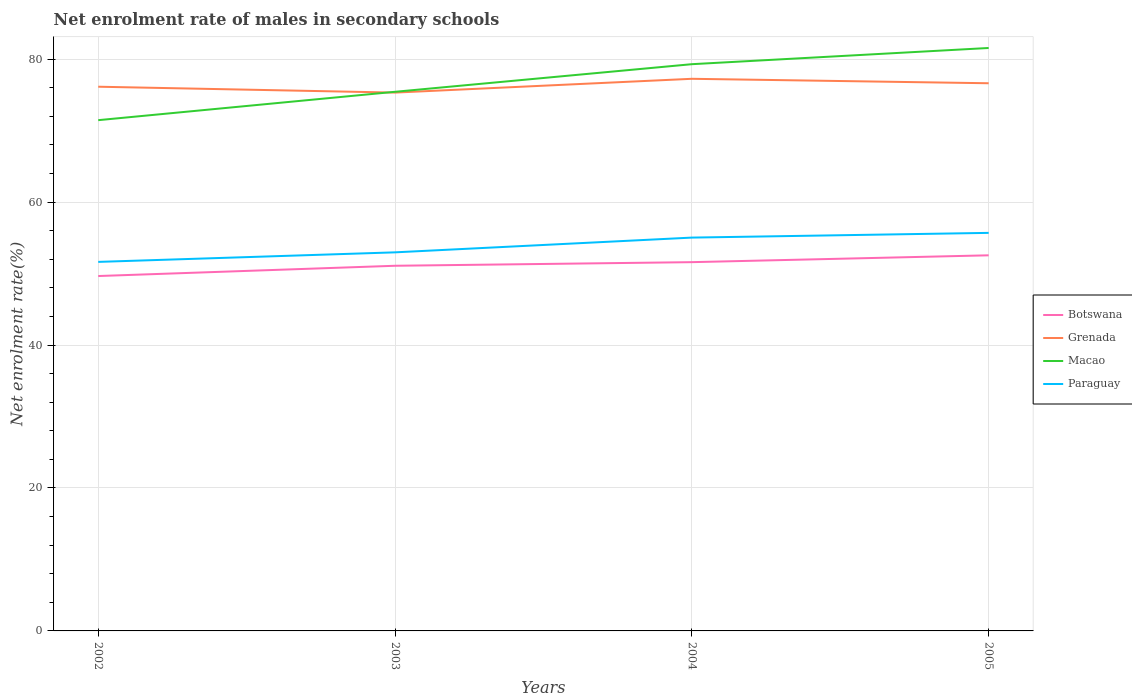How many different coloured lines are there?
Offer a very short reply. 4. Is the number of lines equal to the number of legend labels?
Offer a terse response. Yes. Across all years, what is the maximum net enrolment rate of males in secondary schools in Botswana?
Your answer should be very brief. 49.65. In which year was the net enrolment rate of males in secondary schools in Paraguay maximum?
Provide a succinct answer. 2002. What is the total net enrolment rate of males in secondary schools in Paraguay in the graph?
Provide a short and direct response. -0.66. What is the difference between the highest and the second highest net enrolment rate of males in secondary schools in Grenada?
Provide a short and direct response. 1.93. How many years are there in the graph?
Ensure brevity in your answer.  4. Are the values on the major ticks of Y-axis written in scientific E-notation?
Make the answer very short. No. Does the graph contain any zero values?
Make the answer very short. No. Does the graph contain grids?
Give a very brief answer. Yes. How many legend labels are there?
Ensure brevity in your answer.  4. What is the title of the graph?
Provide a succinct answer. Net enrolment rate of males in secondary schools. Does "Chile" appear as one of the legend labels in the graph?
Give a very brief answer. No. What is the label or title of the X-axis?
Ensure brevity in your answer.  Years. What is the label or title of the Y-axis?
Your answer should be very brief. Net enrolment rate(%). What is the Net enrolment rate(%) in Botswana in 2002?
Provide a succinct answer. 49.65. What is the Net enrolment rate(%) of Grenada in 2002?
Provide a succinct answer. 76.14. What is the Net enrolment rate(%) in Macao in 2002?
Keep it short and to the point. 71.46. What is the Net enrolment rate(%) in Paraguay in 2002?
Your response must be concise. 51.63. What is the Net enrolment rate(%) of Botswana in 2003?
Offer a terse response. 51.09. What is the Net enrolment rate(%) in Grenada in 2003?
Your response must be concise. 75.32. What is the Net enrolment rate(%) in Macao in 2003?
Your response must be concise. 75.43. What is the Net enrolment rate(%) of Paraguay in 2003?
Your answer should be compact. 52.96. What is the Net enrolment rate(%) in Botswana in 2004?
Provide a succinct answer. 51.59. What is the Net enrolment rate(%) of Grenada in 2004?
Your answer should be compact. 77.24. What is the Net enrolment rate(%) of Macao in 2004?
Keep it short and to the point. 79.29. What is the Net enrolment rate(%) in Paraguay in 2004?
Offer a terse response. 55.03. What is the Net enrolment rate(%) in Botswana in 2005?
Keep it short and to the point. 52.55. What is the Net enrolment rate(%) in Grenada in 2005?
Your response must be concise. 76.62. What is the Net enrolment rate(%) of Macao in 2005?
Keep it short and to the point. 81.56. What is the Net enrolment rate(%) in Paraguay in 2005?
Offer a terse response. 55.69. Across all years, what is the maximum Net enrolment rate(%) of Botswana?
Keep it short and to the point. 52.55. Across all years, what is the maximum Net enrolment rate(%) in Grenada?
Offer a very short reply. 77.24. Across all years, what is the maximum Net enrolment rate(%) of Macao?
Make the answer very short. 81.56. Across all years, what is the maximum Net enrolment rate(%) in Paraguay?
Provide a short and direct response. 55.69. Across all years, what is the minimum Net enrolment rate(%) in Botswana?
Offer a terse response. 49.65. Across all years, what is the minimum Net enrolment rate(%) in Grenada?
Offer a terse response. 75.32. Across all years, what is the minimum Net enrolment rate(%) in Macao?
Your answer should be very brief. 71.46. Across all years, what is the minimum Net enrolment rate(%) in Paraguay?
Provide a short and direct response. 51.63. What is the total Net enrolment rate(%) of Botswana in the graph?
Ensure brevity in your answer.  204.88. What is the total Net enrolment rate(%) in Grenada in the graph?
Ensure brevity in your answer.  305.32. What is the total Net enrolment rate(%) in Macao in the graph?
Make the answer very short. 307.73. What is the total Net enrolment rate(%) in Paraguay in the graph?
Offer a terse response. 215.31. What is the difference between the Net enrolment rate(%) of Botswana in 2002 and that in 2003?
Provide a short and direct response. -1.44. What is the difference between the Net enrolment rate(%) of Grenada in 2002 and that in 2003?
Make the answer very short. 0.82. What is the difference between the Net enrolment rate(%) of Macao in 2002 and that in 2003?
Offer a very short reply. -3.97. What is the difference between the Net enrolment rate(%) of Paraguay in 2002 and that in 2003?
Keep it short and to the point. -1.34. What is the difference between the Net enrolment rate(%) in Botswana in 2002 and that in 2004?
Offer a very short reply. -1.94. What is the difference between the Net enrolment rate(%) of Grenada in 2002 and that in 2004?
Offer a terse response. -1.11. What is the difference between the Net enrolment rate(%) in Macao in 2002 and that in 2004?
Provide a succinct answer. -7.83. What is the difference between the Net enrolment rate(%) in Paraguay in 2002 and that in 2004?
Ensure brevity in your answer.  -3.4. What is the difference between the Net enrolment rate(%) in Botswana in 2002 and that in 2005?
Provide a succinct answer. -2.9. What is the difference between the Net enrolment rate(%) in Grenada in 2002 and that in 2005?
Your answer should be compact. -0.48. What is the difference between the Net enrolment rate(%) in Macao in 2002 and that in 2005?
Provide a short and direct response. -10.1. What is the difference between the Net enrolment rate(%) in Paraguay in 2002 and that in 2005?
Your answer should be compact. -4.06. What is the difference between the Net enrolment rate(%) of Botswana in 2003 and that in 2004?
Keep it short and to the point. -0.51. What is the difference between the Net enrolment rate(%) in Grenada in 2003 and that in 2004?
Your response must be concise. -1.93. What is the difference between the Net enrolment rate(%) of Macao in 2003 and that in 2004?
Keep it short and to the point. -3.86. What is the difference between the Net enrolment rate(%) in Paraguay in 2003 and that in 2004?
Offer a very short reply. -2.06. What is the difference between the Net enrolment rate(%) of Botswana in 2003 and that in 2005?
Your answer should be compact. -1.46. What is the difference between the Net enrolment rate(%) of Grenada in 2003 and that in 2005?
Keep it short and to the point. -1.31. What is the difference between the Net enrolment rate(%) in Macao in 2003 and that in 2005?
Make the answer very short. -6.13. What is the difference between the Net enrolment rate(%) in Paraguay in 2003 and that in 2005?
Provide a succinct answer. -2.72. What is the difference between the Net enrolment rate(%) in Botswana in 2004 and that in 2005?
Provide a short and direct response. -0.96. What is the difference between the Net enrolment rate(%) of Grenada in 2004 and that in 2005?
Ensure brevity in your answer.  0.62. What is the difference between the Net enrolment rate(%) in Macao in 2004 and that in 2005?
Offer a very short reply. -2.27. What is the difference between the Net enrolment rate(%) of Paraguay in 2004 and that in 2005?
Keep it short and to the point. -0.66. What is the difference between the Net enrolment rate(%) in Botswana in 2002 and the Net enrolment rate(%) in Grenada in 2003?
Offer a terse response. -25.66. What is the difference between the Net enrolment rate(%) in Botswana in 2002 and the Net enrolment rate(%) in Macao in 2003?
Provide a short and direct response. -25.78. What is the difference between the Net enrolment rate(%) of Botswana in 2002 and the Net enrolment rate(%) of Paraguay in 2003?
Your answer should be very brief. -3.31. What is the difference between the Net enrolment rate(%) in Grenada in 2002 and the Net enrolment rate(%) in Macao in 2003?
Provide a short and direct response. 0.71. What is the difference between the Net enrolment rate(%) of Grenada in 2002 and the Net enrolment rate(%) of Paraguay in 2003?
Make the answer very short. 23.17. What is the difference between the Net enrolment rate(%) of Macao in 2002 and the Net enrolment rate(%) of Paraguay in 2003?
Offer a terse response. 18.49. What is the difference between the Net enrolment rate(%) of Botswana in 2002 and the Net enrolment rate(%) of Grenada in 2004?
Keep it short and to the point. -27.59. What is the difference between the Net enrolment rate(%) of Botswana in 2002 and the Net enrolment rate(%) of Macao in 2004?
Make the answer very short. -29.64. What is the difference between the Net enrolment rate(%) in Botswana in 2002 and the Net enrolment rate(%) in Paraguay in 2004?
Keep it short and to the point. -5.38. What is the difference between the Net enrolment rate(%) of Grenada in 2002 and the Net enrolment rate(%) of Macao in 2004?
Your answer should be compact. -3.15. What is the difference between the Net enrolment rate(%) of Grenada in 2002 and the Net enrolment rate(%) of Paraguay in 2004?
Offer a very short reply. 21.11. What is the difference between the Net enrolment rate(%) of Macao in 2002 and the Net enrolment rate(%) of Paraguay in 2004?
Your response must be concise. 16.43. What is the difference between the Net enrolment rate(%) in Botswana in 2002 and the Net enrolment rate(%) in Grenada in 2005?
Provide a succinct answer. -26.97. What is the difference between the Net enrolment rate(%) of Botswana in 2002 and the Net enrolment rate(%) of Macao in 2005?
Ensure brevity in your answer.  -31.91. What is the difference between the Net enrolment rate(%) of Botswana in 2002 and the Net enrolment rate(%) of Paraguay in 2005?
Your response must be concise. -6.04. What is the difference between the Net enrolment rate(%) of Grenada in 2002 and the Net enrolment rate(%) of Macao in 2005?
Your answer should be compact. -5.42. What is the difference between the Net enrolment rate(%) in Grenada in 2002 and the Net enrolment rate(%) in Paraguay in 2005?
Keep it short and to the point. 20.45. What is the difference between the Net enrolment rate(%) in Macao in 2002 and the Net enrolment rate(%) in Paraguay in 2005?
Your response must be concise. 15.77. What is the difference between the Net enrolment rate(%) in Botswana in 2003 and the Net enrolment rate(%) in Grenada in 2004?
Make the answer very short. -26.16. What is the difference between the Net enrolment rate(%) in Botswana in 2003 and the Net enrolment rate(%) in Macao in 2004?
Ensure brevity in your answer.  -28.2. What is the difference between the Net enrolment rate(%) in Botswana in 2003 and the Net enrolment rate(%) in Paraguay in 2004?
Your answer should be compact. -3.94. What is the difference between the Net enrolment rate(%) of Grenada in 2003 and the Net enrolment rate(%) of Macao in 2004?
Provide a short and direct response. -3.97. What is the difference between the Net enrolment rate(%) in Grenada in 2003 and the Net enrolment rate(%) in Paraguay in 2004?
Give a very brief answer. 20.29. What is the difference between the Net enrolment rate(%) in Macao in 2003 and the Net enrolment rate(%) in Paraguay in 2004?
Offer a very short reply. 20.4. What is the difference between the Net enrolment rate(%) in Botswana in 2003 and the Net enrolment rate(%) in Grenada in 2005?
Make the answer very short. -25.53. What is the difference between the Net enrolment rate(%) of Botswana in 2003 and the Net enrolment rate(%) of Macao in 2005?
Offer a terse response. -30.47. What is the difference between the Net enrolment rate(%) in Botswana in 2003 and the Net enrolment rate(%) in Paraguay in 2005?
Your answer should be very brief. -4.6. What is the difference between the Net enrolment rate(%) of Grenada in 2003 and the Net enrolment rate(%) of Macao in 2005?
Make the answer very short. -6.24. What is the difference between the Net enrolment rate(%) in Grenada in 2003 and the Net enrolment rate(%) in Paraguay in 2005?
Your answer should be very brief. 19.63. What is the difference between the Net enrolment rate(%) of Macao in 2003 and the Net enrolment rate(%) of Paraguay in 2005?
Offer a terse response. 19.74. What is the difference between the Net enrolment rate(%) in Botswana in 2004 and the Net enrolment rate(%) in Grenada in 2005?
Offer a very short reply. -25.03. What is the difference between the Net enrolment rate(%) of Botswana in 2004 and the Net enrolment rate(%) of Macao in 2005?
Offer a terse response. -29.96. What is the difference between the Net enrolment rate(%) in Botswana in 2004 and the Net enrolment rate(%) in Paraguay in 2005?
Offer a very short reply. -4.1. What is the difference between the Net enrolment rate(%) of Grenada in 2004 and the Net enrolment rate(%) of Macao in 2005?
Offer a very short reply. -4.31. What is the difference between the Net enrolment rate(%) of Grenada in 2004 and the Net enrolment rate(%) of Paraguay in 2005?
Your response must be concise. 21.56. What is the difference between the Net enrolment rate(%) in Macao in 2004 and the Net enrolment rate(%) in Paraguay in 2005?
Your answer should be very brief. 23.6. What is the average Net enrolment rate(%) in Botswana per year?
Offer a terse response. 51.22. What is the average Net enrolment rate(%) of Grenada per year?
Offer a terse response. 76.33. What is the average Net enrolment rate(%) of Macao per year?
Your response must be concise. 76.93. What is the average Net enrolment rate(%) of Paraguay per year?
Offer a very short reply. 53.83. In the year 2002, what is the difference between the Net enrolment rate(%) in Botswana and Net enrolment rate(%) in Grenada?
Offer a terse response. -26.49. In the year 2002, what is the difference between the Net enrolment rate(%) of Botswana and Net enrolment rate(%) of Macao?
Keep it short and to the point. -21.81. In the year 2002, what is the difference between the Net enrolment rate(%) in Botswana and Net enrolment rate(%) in Paraguay?
Make the answer very short. -1.98. In the year 2002, what is the difference between the Net enrolment rate(%) in Grenada and Net enrolment rate(%) in Macao?
Your answer should be compact. 4.68. In the year 2002, what is the difference between the Net enrolment rate(%) in Grenada and Net enrolment rate(%) in Paraguay?
Your answer should be compact. 24.51. In the year 2002, what is the difference between the Net enrolment rate(%) in Macao and Net enrolment rate(%) in Paraguay?
Provide a short and direct response. 19.83. In the year 2003, what is the difference between the Net enrolment rate(%) in Botswana and Net enrolment rate(%) in Grenada?
Your answer should be very brief. -24.23. In the year 2003, what is the difference between the Net enrolment rate(%) of Botswana and Net enrolment rate(%) of Macao?
Your answer should be very brief. -24.34. In the year 2003, what is the difference between the Net enrolment rate(%) of Botswana and Net enrolment rate(%) of Paraguay?
Ensure brevity in your answer.  -1.88. In the year 2003, what is the difference between the Net enrolment rate(%) in Grenada and Net enrolment rate(%) in Macao?
Offer a terse response. -0.11. In the year 2003, what is the difference between the Net enrolment rate(%) in Grenada and Net enrolment rate(%) in Paraguay?
Your response must be concise. 22.35. In the year 2003, what is the difference between the Net enrolment rate(%) in Macao and Net enrolment rate(%) in Paraguay?
Provide a succinct answer. 22.46. In the year 2004, what is the difference between the Net enrolment rate(%) in Botswana and Net enrolment rate(%) in Grenada?
Ensure brevity in your answer.  -25.65. In the year 2004, what is the difference between the Net enrolment rate(%) of Botswana and Net enrolment rate(%) of Macao?
Your answer should be very brief. -27.7. In the year 2004, what is the difference between the Net enrolment rate(%) of Botswana and Net enrolment rate(%) of Paraguay?
Give a very brief answer. -3.44. In the year 2004, what is the difference between the Net enrolment rate(%) in Grenada and Net enrolment rate(%) in Macao?
Ensure brevity in your answer.  -2.04. In the year 2004, what is the difference between the Net enrolment rate(%) in Grenada and Net enrolment rate(%) in Paraguay?
Offer a terse response. 22.22. In the year 2004, what is the difference between the Net enrolment rate(%) in Macao and Net enrolment rate(%) in Paraguay?
Keep it short and to the point. 24.26. In the year 2005, what is the difference between the Net enrolment rate(%) of Botswana and Net enrolment rate(%) of Grenada?
Offer a very short reply. -24.07. In the year 2005, what is the difference between the Net enrolment rate(%) in Botswana and Net enrolment rate(%) in Macao?
Your answer should be compact. -29.01. In the year 2005, what is the difference between the Net enrolment rate(%) of Botswana and Net enrolment rate(%) of Paraguay?
Your answer should be very brief. -3.14. In the year 2005, what is the difference between the Net enrolment rate(%) in Grenada and Net enrolment rate(%) in Macao?
Your answer should be compact. -4.93. In the year 2005, what is the difference between the Net enrolment rate(%) of Grenada and Net enrolment rate(%) of Paraguay?
Keep it short and to the point. 20.93. In the year 2005, what is the difference between the Net enrolment rate(%) in Macao and Net enrolment rate(%) in Paraguay?
Ensure brevity in your answer.  25.87. What is the ratio of the Net enrolment rate(%) in Botswana in 2002 to that in 2003?
Ensure brevity in your answer.  0.97. What is the ratio of the Net enrolment rate(%) of Grenada in 2002 to that in 2003?
Give a very brief answer. 1.01. What is the ratio of the Net enrolment rate(%) of Paraguay in 2002 to that in 2003?
Your response must be concise. 0.97. What is the ratio of the Net enrolment rate(%) of Botswana in 2002 to that in 2004?
Ensure brevity in your answer.  0.96. What is the ratio of the Net enrolment rate(%) of Grenada in 2002 to that in 2004?
Provide a succinct answer. 0.99. What is the ratio of the Net enrolment rate(%) in Macao in 2002 to that in 2004?
Provide a succinct answer. 0.9. What is the ratio of the Net enrolment rate(%) in Paraguay in 2002 to that in 2004?
Your response must be concise. 0.94. What is the ratio of the Net enrolment rate(%) of Botswana in 2002 to that in 2005?
Keep it short and to the point. 0.94. What is the ratio of the Net enrolment rate(%) of Macao in 2002 to that in 2005?
Ensure brevity in your answer.  0.88. What is the ratio of the Net enrolment rate(%) of Paraguay in 2002 to that in 2005?
Provide a short and direct response. 0.93. What is the ratio of the Net enrolment rate(%) of Botswana in 2003 to that in 2004?
Your answer should be compact. 0.99. What is the ratio of the Net enrolment rate(%) of Grenada in 2003 to that in 2004?
Ensure brevity in your answer.  0.97. What is the ratio of the Net enrolment rate(%) in Macao in 2003 to that in 2004?
Provide a succinct answer. 0.95. What is the ratio of the Net enrolment rate(%) of Paraguay in 2003 to that in 2004?
Provide a short and direct response. 0.96. What is the ratio of the Net enrolment rate(%) of Botswana in 2003 to that in 2005?
Keep it short and to the point. 0.97. What is the ratio of the Net enrolment rate(%) in Grenada in 2003 to that in 2005?
Provide a short and direct response. 0.98. What is the ratio of the Net enrolment rate(%) in Macao in 2003 to that in 2005?
Ensure brevity in your answer.  0.92. What is the ratio of the Net enrolment rate(%) in Paraguay in 2003 to that in 2005?
Your answer should be compact. 0.95. What is the ratio of the Net enrolment rate(%) in Botswana in 2004 to that in 2005?
Offer a terse response. 0.98. What is the ratio of the Net enrolment rate(%) of Macao in 2004 to that in 2005?
Make the answer very short. 0.97. What is the difference between the highest and the second highest Net enrolment rate(%) of Botswana?
Give a very brief answer. 0.96. What is the difference between the highest and the second highest Net enrolment rate(%) in Grenada?
Provide a short and direct response. 0.62. What is the difference between the highest and the second highest Net enrolment rate(%) in Macao?
Your answer should be very brief. 2.27. What is the difference between the highest and the second highest Net enrolment rate(%) in Paraguay?
Your response must be concise. 0.66. What is the difference between the highest and the lowest Net enrolment rate(%) in Botswana?
Make the answer very short. 2.9. What is the difference between the highest and the lowest Net enrolment rate(%) in Grenada?
Your response must be concise. 1.93. What is the difference between the highest and the lowest Net enrolment rate(%) in Macao?
Ensure brevity in your answer.  10.1. What is the difference between the highest and the lowest Net enrolment rate(%) of Paraguay?
Offer a very short reply. 4.06. 